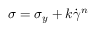Convert formula to latex. <formula><loc_0><loc_0><loc_500><loc_500>\sigma = \sigma _ { y } + k \dot { \gamma } ^ { n }</formula> 